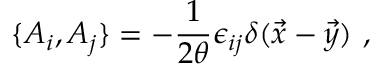Convert formula to latex. <formula><loc_0><loc_0><loc_500><loc_500>\{ A _ { i } , A _ { j } \} = - { \frac { 1 } { 2 \theta } } \epsilon _ { i j } \delta ( \vec { x } - \vec { y } ) ,</formula> 